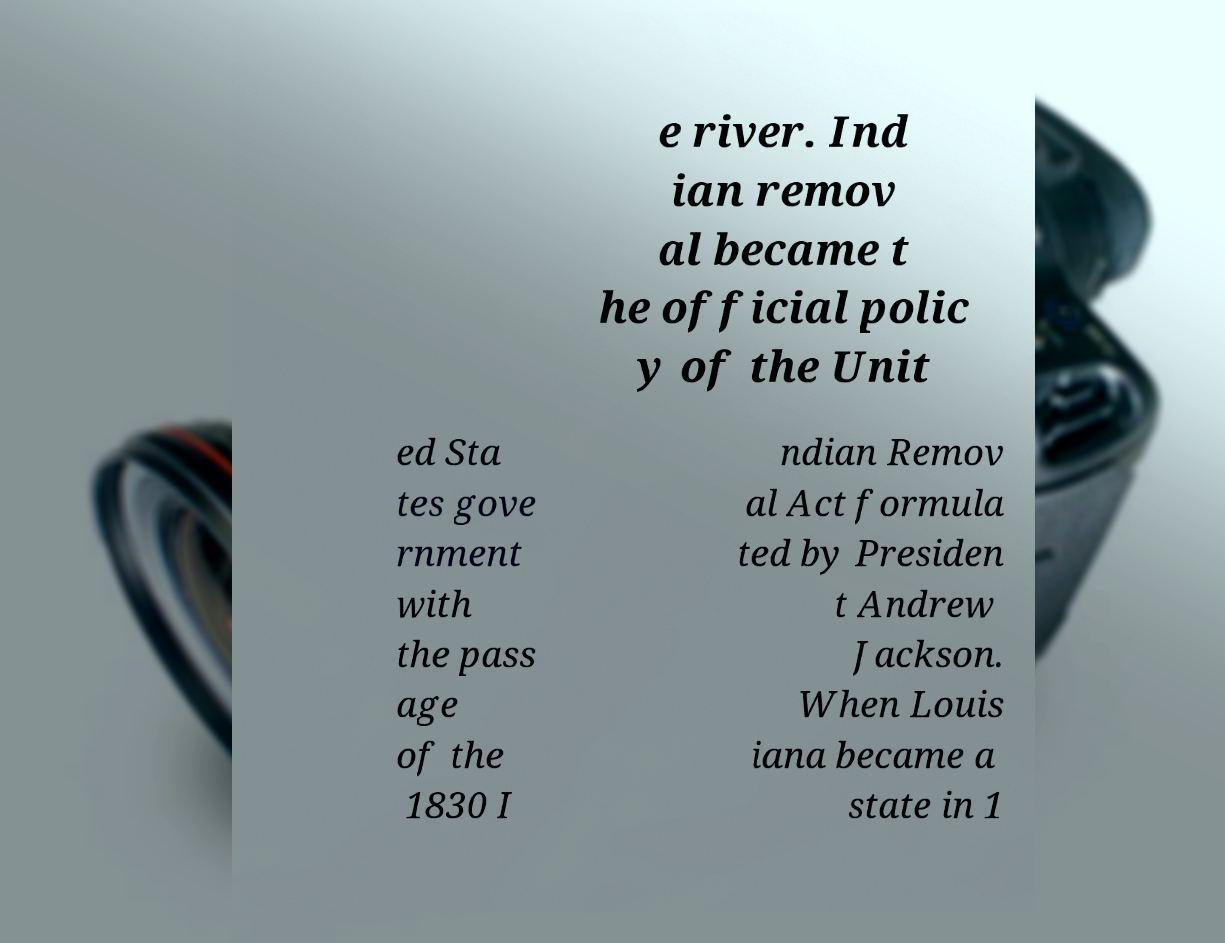Can you accurately transcribe the text from the provided image for me? e river. Ind ian remov al became t he official polic y of the Unit ed Sta tes gove rnment with the pass age of the 1830 I ndian Remov al Act formula ted by Presiden t Andrew Jackson. When Louis iana became a state in 1 